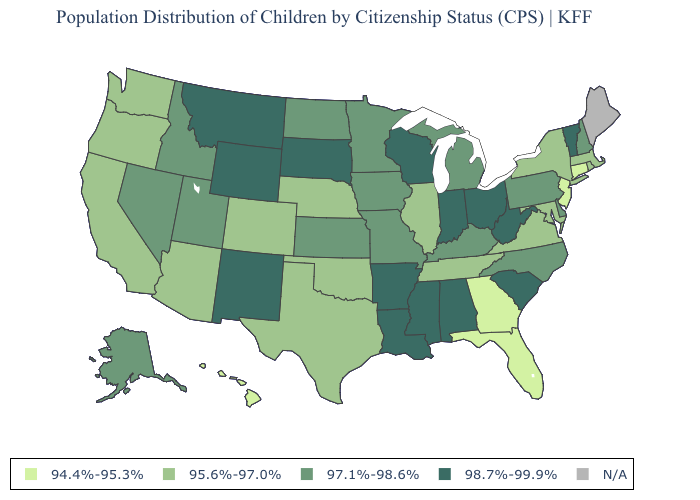Does South Carolina have the highest value in the South?
Keep it brief. Yes. What is the value of New York?
Give a very brief answer. 95.6%-97.0%. Name the states that have a value in the range 97.1%-98.6%?
Write a very short answer. Alaska, Delaware, Idaho, Iowa, Kansas, Kentucky, Michigan, Minnesota, Missouri, Nevada, New Hampshire, North Carolina, North Dakota, Pennsylvania, Utah. Which states have the lowest value in the USA?
Quick response, please. Connecticut, Florida, Georgia, Hawaii, New Jersey. Among the states that border North Dakota , does Minnesota have the highest value?
Give a very brief answer. No. Name the states that have a value in the range 97.1%-98.6%?
Short answer required. Alaska, Delaware, Idaho, Iowa, Kansas, Kentucky, Michigan, Minnesota, Missouri, Nevada, New Hampshire, North Carolina, North Dakota, Pennsylvania, Utah. What is the value of Alaska?
Be succinct. 97.1%-98.6%. Which states have the lowest value in the USA?
Quick response, please. Connecticut, Florida, Georgia, Hawaii, New Jersey. Name the states that have a value in the range 97.1%-98.6%?
Give a very brief answer. Alaska, Delaware, Idaho, Iowa, Kansas, Kentucky, Michigan, Minnesota, Missouri, Nevada, New Hampshire, North Carolina, North Dakota, Pennsylvania, Utah. What is the highest value in states that border Nevada?
Be succinct. 97.1%-98.6%. What is the lowest value in the USA?
Answer briefly. 94.4%-95.3%. What is the value of New Jersey?
Answer briefly. 94.4%-95.3%. What is the highest value in the MidWest ?
Answer briefly. 98.7%-99.9%. 